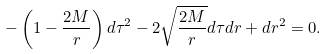<formula> <loc_0><loc_0><loc_500><loc_500>- \left ( 1 - \frac { 2 M } { r } \right ) d \tau ^ { 2 } - 2 \sqrt { \frac { 2 M } { r } } d \tau d r + d r ^ { 2 } = 0 .</formula> 